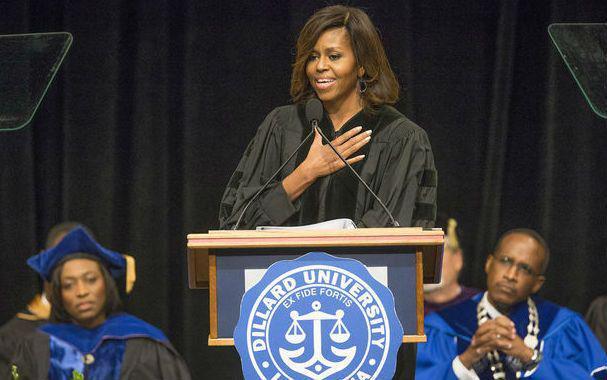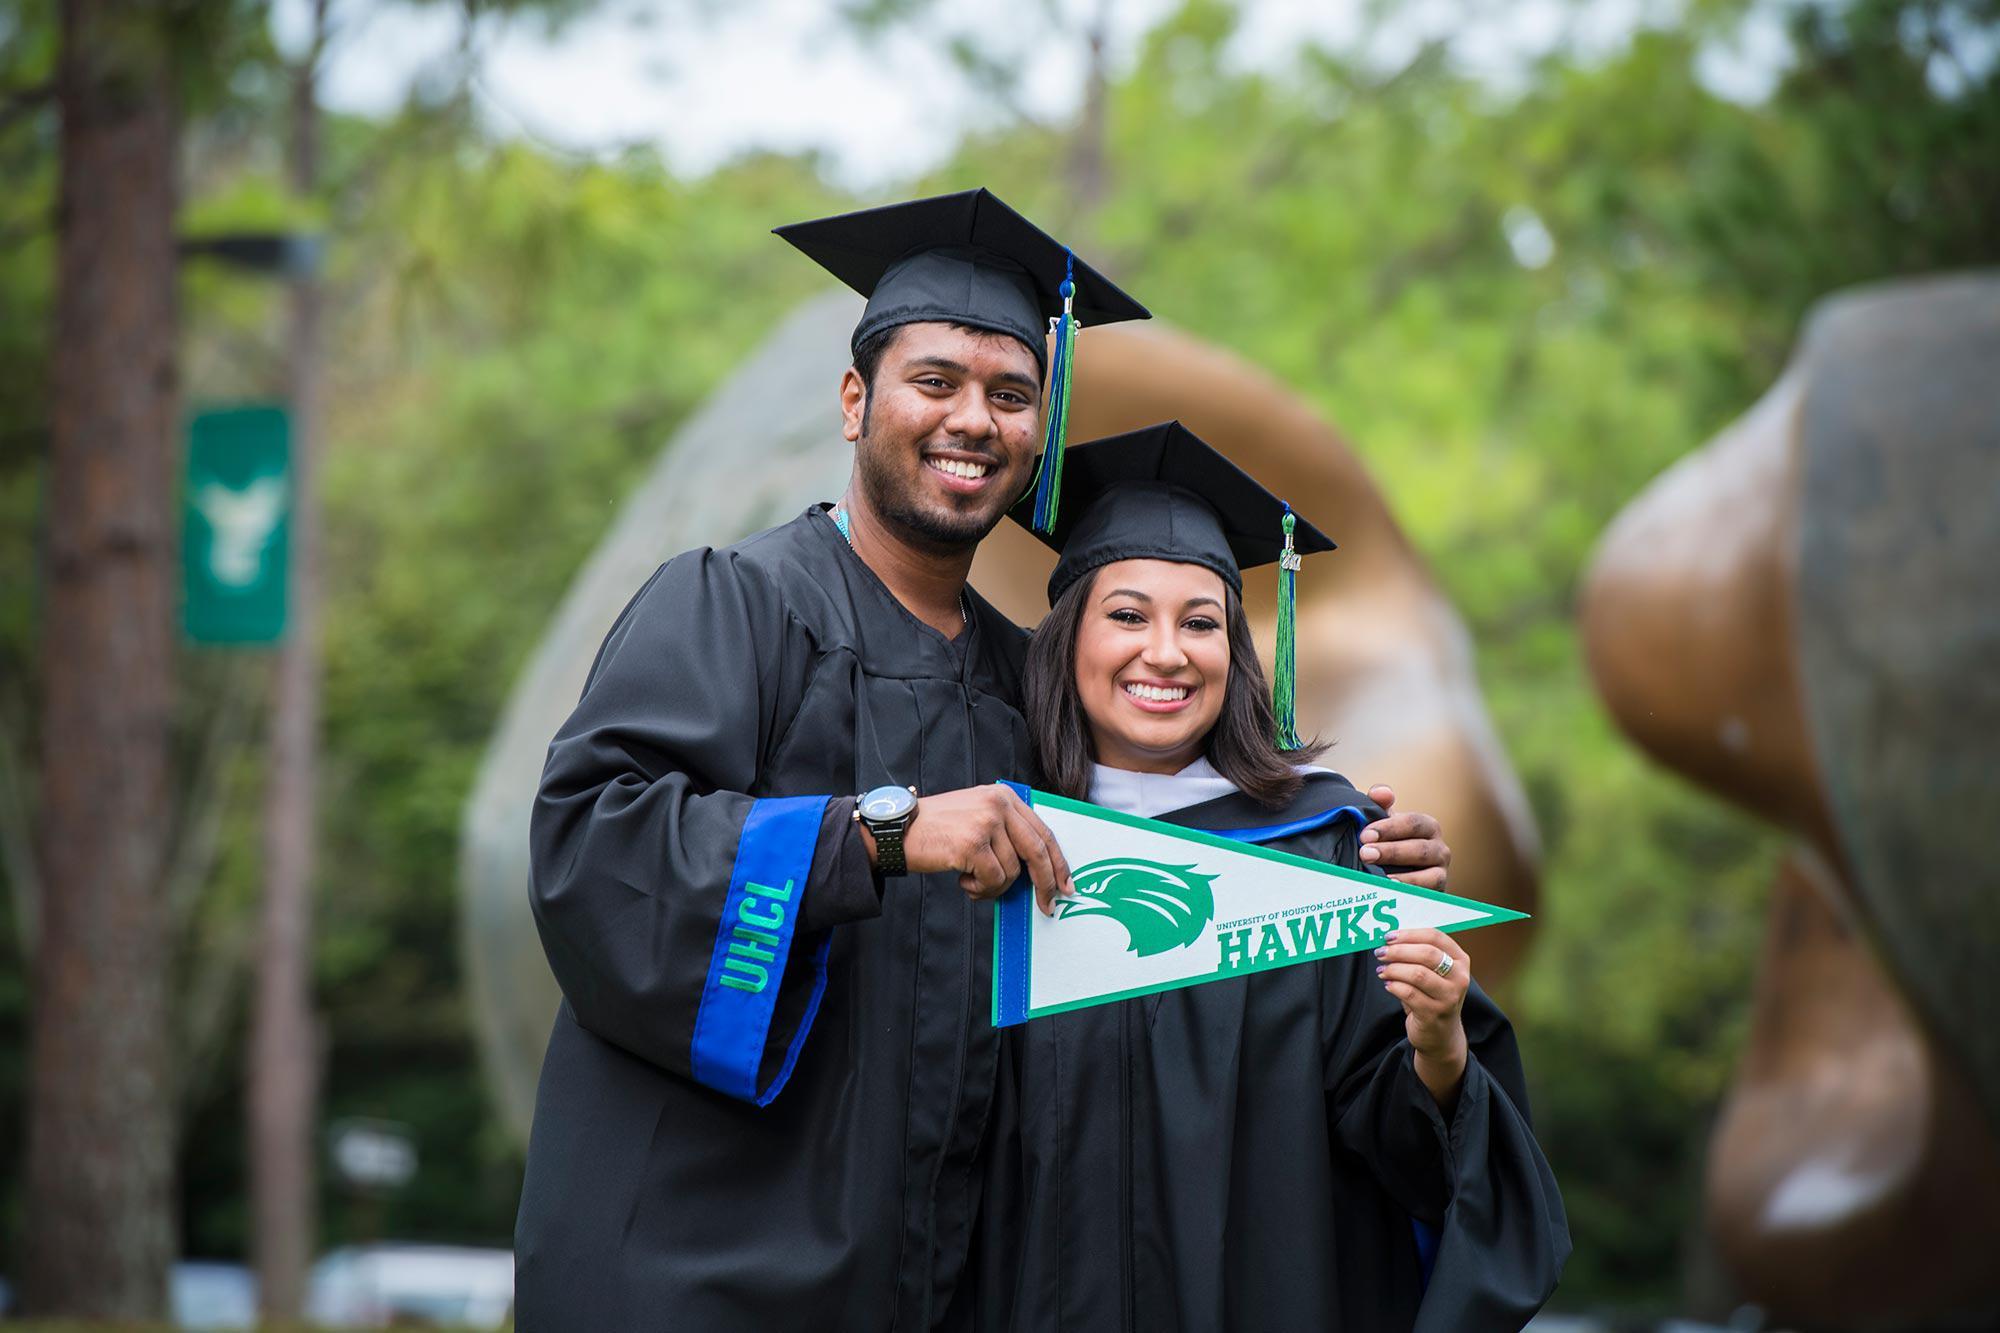The first image is the image on the left, the second image is the image on the right. Assess this claim about the two images: "Two people, a woman and a man, are wearing graduation attire in the image on the right.". Correct or not? Answer yes or no. Yes. The first image is the image on the left, the second image is the image on the right. Considering the images on both sides, is "An image shows two side-by-side camera-facing graduates who together hold up a single object in front of them." valid? Answer yes or no. Yes. 